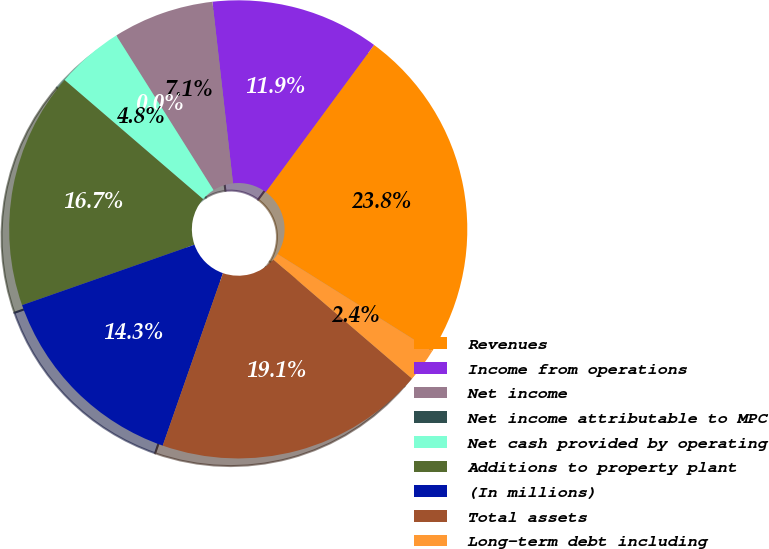Convert chart to OTSL. <chart><loc_0><loc_0><loc_500><loc_500><pie_chart><fcel>Revenues<fcel>Income from operations<fcel>Net income<fcel>Net income attributable to MPC<fcel>Net cash provided by operating<fcel>Additions to property plant<fcel>(In millions)<fcel>Total assets<fcel>Long-term debt including<nl><fcel>23.81%<fcel>11.9%<fcel>7.14%<fcel>0.0%<fcel>4.76%<fcel>16.67%<fcel>14.29%<fcel>19.05%<fcel>2.38%<nl></chart> 